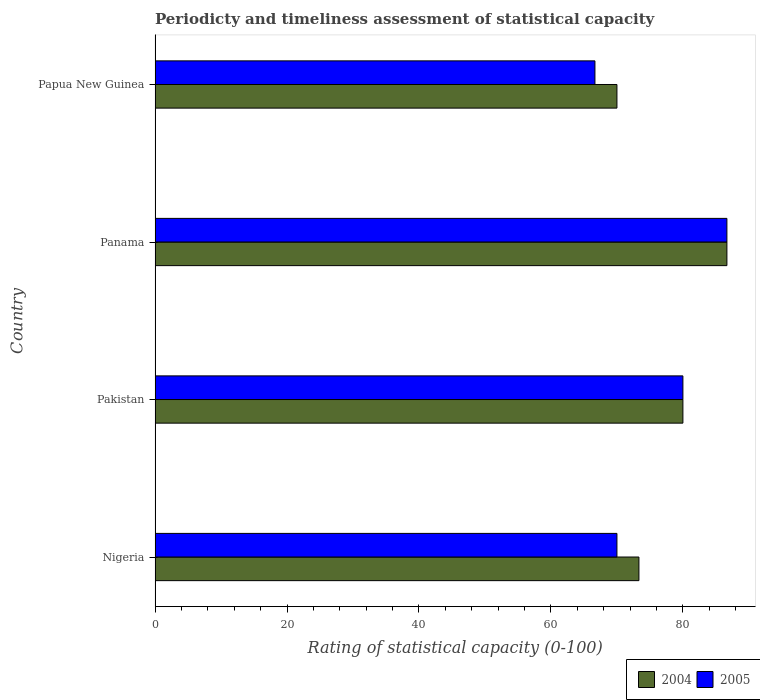Are the number of bars on each tick of the Y-axis equal?
Offer a very short reply. Yes. How many bars are there on the 4th tick from the bottom?
Give a very brief answer. 2. What is the label of the 2nd group of bars from the top?
Your answer should be very brief. Panama. What is the rating of statistical capacity in 2005 in Nigeria?
Keep it short and to the point. 70. Across all countries, what is the maximum rating of statistical capacity in 2005?
Your response must be concise. 86.67. Across all countries, what is the minimum rating of statistical capacity in 2005?
Give a very brief answer. 66.67. In which country was the rating of statistical capacity in 2005 maximum?
Provide a succinct answer. Panama. In which country was the rating of statistical capacity in 2004 minimum?
Offer a terse response. Papua New Guinea. What is the total rating of statistical capacity in 2004 in the graph?
Keep it short and to the point. 310. What is the difference between the rating of statistical capacity in 2005 in Nigeria and that in Pakistan?
Provide a short and direct response. -10. What is the average rating of statistical capacity in 2004 per country?
Provide a succinct answer. 77.5. What is the difference between the rating of statistical capacity in 2005 and rating of statistical capacity in 2004 in Nigeria?
Give a very brief answer. -3.33. What is the ratio of the rating of statistical capacity in 2005 in Pakistan to that in Panama?
Make the answer very short. 0.92. What is the difference between the highest and the second highest rating of statistical capacity in 2004?
Your answer should be compact. 6.67. Is the sum of the rating of statistical capacity in 2004 in Nigeria and Papua New Guinea greater than the maximum rating of statistical capacity in 2005 across all countries?
Offer a terse response. Yes. What does the 2nd bar from the top in Papua New Guinea represents?
Provide a succinct answer. 2004. How many bars are there?
Keep it short and to the point. 8. Are all the bars in the graph horizontal?
Keep it short and to the point. Yes. How many countries are there in the graph?
Your answer should be very brief. 4. What is the difference between two consecutive major ticks on the X-axis?
Your answer should be very brief. 20. Are the values on the major ticks of X-axis written in scientific E-notation?
Give a very brief answer. No. How are the legend labels stacked?
Provide a short and direct response. Horizontal. What is the title of the graph?
Your response must be concise. Periodicty and timeliness assessment of statistical capacity. What is the label or title of the X-axis?
Your response must be concise. Rating of statistical capacity (0-100). What is the Rating of statistical capacity (0-100) of 2004 in Nigeria?
Provide a short and direct response. 73.33. What is the Rating of statistical capacity (0-100) in 2004 in Pakistan?
Your answer should be compact. 80. What is the Rating of statistical capacity (0-100) in 2005 in Pakistan?
Offer a terse response. 80. What is the Rating of statistical capacity (0-100) in 2004 in Panama?
Your answer should be compact. 86.67. What is the Rating of statistical capacity (0-100) in 2005 in Panama?
Offer a terse response. 86.67. What is the Rating of statistical capacity (0-100) of 2004 in Papua New Guinea?
Provide a short and direct response. 70. What is the Rating of statistical capacity (0-100) of 2005 in Papua New Guinea?
Your response must be concise. 66.67. Across all countries, what is the maximum Rating of statistical capacity (0-100) in 2004?
Your response must be concise. 86.67. Across all countries, what is the maximum Rating of statistical capacity (0-100) of 2005?
Ensure brevity in your answer.  86.67. Across all countries, what is the minimum Rating of statistical capacity (0-100) of 2004?
Your response must be concise. 70. Across all countries, what is the minimum Rating of statistical capacity (0-100) of 2005?
Make the answer very short. 66.67. What is the total Rating of statistical capacity (0-100) in 2004 in the graph?
Keep it short and to the point. 310. What is the total Rating of statistical capacity (0-100) in 2005 in the graph?
Your response must be concise. 303.33. What is the difference between the Rating of statistical capacity (0-100) in 2004 in Nigeria and that in Pakistan?
Ensure brevity in your answer.  -6.67. What is the difference between the Rating of statistical capacity (0-100) in 2005 in Nigeria and that in Pakistan?
Offer a terse response. -10. What is the difference between the Rating of statistical capacity (0-100) of 2004 in Nigeria and that in Panama?
Make the answer very short. -13.33. What is the difference between the Rating of statistical capacity (0-100) in 2005 in Nigeria and that in Panama?
Offer a terse response. -16.67. What is the difference between the Rating of statistical capacity (0-100) in 2005 in Nigeria and that in Papua New Guinea?
Offer a very short reply. 3.33. What is the difference between the Rating of statistical capacity (0-100) in 2004 in Pakistan and that in Panama?
Give a very brief answer. -6.67. What is the difference between the Rating of statistical capacity (0-100) of 2005 in Pakistan and that in Panama?
Offer a very short reply. -6.67. What is the difference between the Rating of statistical capacity (0-100) of 2005 in Pakistan and that in Papua New Guinea?
Your answer should be compact. 13.33. What is the difference between the Rating of statistical capacity (0-100) of 2004 in Panama and that in Papua New Guinea?
Your response must be concise. 16.67. What is the difference between the Rating of statistical capacity (0-100) in 2005 in Panama and that in Papua New Guinea?
Your answer should be compact. 20. What is the difference between the Rating of statistical capacity (0-100) in 2004 in Nigeria and the Rating of statistical capacity (0-100) in 2005 in Pakistan?
Your response must be concise. -6.67. What is the difference between the Rating of statistical capacity (0-100) in 2004 in Nigeria and the Rating of statistical capacity (0-100) in 2005 in Panama?
Offer a terse response. -13.33. What is the difference between the Rating of statistical capacity (0-100) of 2004 in Nigeria and the Rating of statistical capacity (0-100) of 2005 in Papua New Guinea?
Your response must be concise. 6.67. What is the difference between the Rating of statistical capacity (0-100) in 2004 in Pakistan and the Rating of statistical capacity (0-100) in 2005 in Panama?
Offer a terse response. -6.67. What is the difference between the Rating of statistical capacity (0-100) in 2004 in Pakistan and the Rating of statistical capacity (0-100) in 2005 in Papua New Guinea?
Offer a terse response. 13.33. What is the average Rating of statistical capacity (0-100) of 2004 per country?
Keep it short and to the point. 77.5. What is the average Rating of statistical capacity (0-100) of 2005 per country?
Ensure brevity in your answer.  75.83. What is the difference between the Rating of statistical capacity (0-100) of 2004 and Rating of statistical capacity (0-100) of 2005 in Nigeria?
Offer a terse response. 3.33. What is the difference between the Rating of statistical capacity (0-100) in 2004 and Rating of statistical capacity (0-100) in 2005 in Pakistan?
Give a very brief answer. 0. What is the difference between the Rating of statistical capacity (0-100) in 2004 and Rating of statistical capacity (0-100) in 2005 in Panama?
Your answer should be very brief. 0. What is the difference between the Rating of statistical capacity (0-100) in 2004 and Rating of statistical capacity (0-100) in 2005 in Papua New Guinea?
Provide a succinct answer. 3.33. What is the ratio of the Rating of statistical capacity (0-100) in 2004 in Nigeria to that in Pakistan?
Provide a succinct answer. 0.92. What is the ratio of the Rating of statistical capacity (0-100) of 2005 in Nigeria to that in Pakistan?
Your response must be concise. 0.88. What is the ratio of the Rating of statistical capacity (0-100) of 2004 in Nigeria to that in Panama?
Give a very brief answer. 0.85. What is the ratio of the Rating of statistical capacity (0-100) in 2005 in Nigeria to that in Panama?
Provide a short and direct response. 0.81. What is the ratio of the Rating of statistical capacity (0-100) in 2004 in Nigeria to that in Papua New Guinea?
Offer a very short reply. 1.05. What is the ratio of the Rating of statistical capacity (0-100) of 2005 in Nigeria to that in Papua New Guinea?
Provide a short and direct response. 1.05. What is the ratio of the Rating of statistical capacity (0-100) in 2004 in Pakistan to that in Panama?
Your answer should be very brief. 0.92. What is the ratio of the Rating of statistical capacity (0-100) in 2004 in Panama to that in Papua New Guinea?
Provide a succinct answer. 1.24. What is the difference between the highest and the lowest Rating of statistical capacity (0-100) in 2004?
Offer a very short reply. 16.67. 